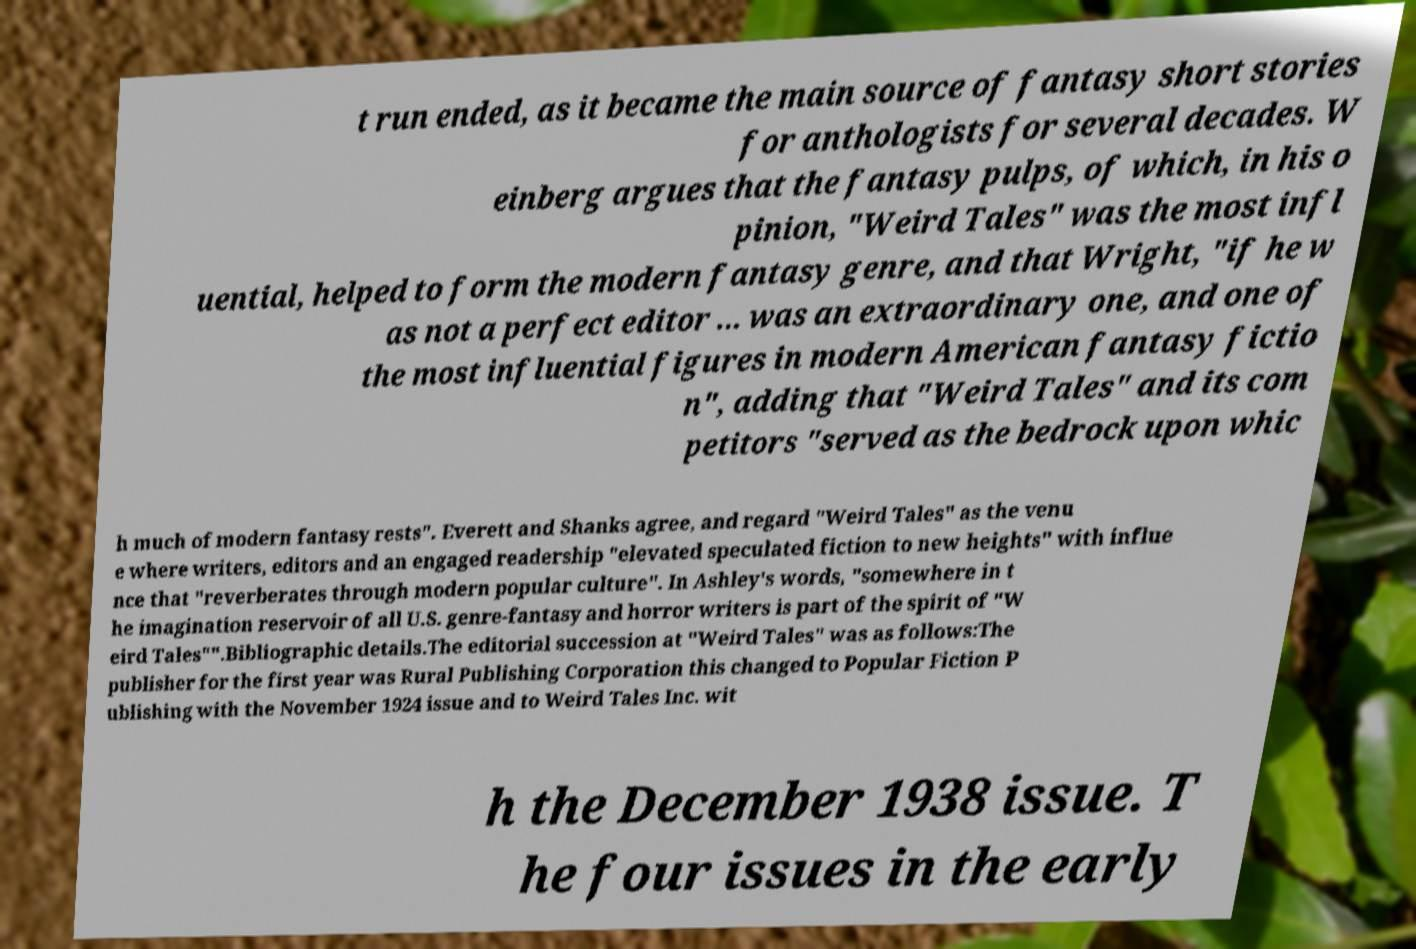Could you extract and type out the text from this image? t run ended, as it became the main source of fantasy short stories for anthologists for several decades. W einberg argues that the fantasy pulps, of which, in his o pinion, "Weird Tales" was the most infl uential, helped to form the modern fantasy genre, and that Wright, "if he w as not a perfect editor ... was an extraordinary one, and one of the most influential figures in modern American fantasy fictio n", adding that "Weird Tales" and its com petitors "served as the bedrock upon whic h much of modern fantasy rests". Everett and Shanks agree, and regard "Weird Tales" as the venu e where writers, editors and an engaged readership "elevated speculated fiction to new heights" with influe nce that "reverberates through modern popular culture". In Ashley's words, "somewhere in t he imagination reservoir of all U.S. genre-fantasy and horror writers is part of the spirit of "W eird Tales"".Bibliographic details.The editorial succession at "Weird Tales" was as follows:The publisher for the first year was Rural Publishing Corporation this changed to Popular Fiction P ublishing with the November 1924 issue and to Weird Tales Inc. wit h the December 1938 issue. T he four issues in the early 